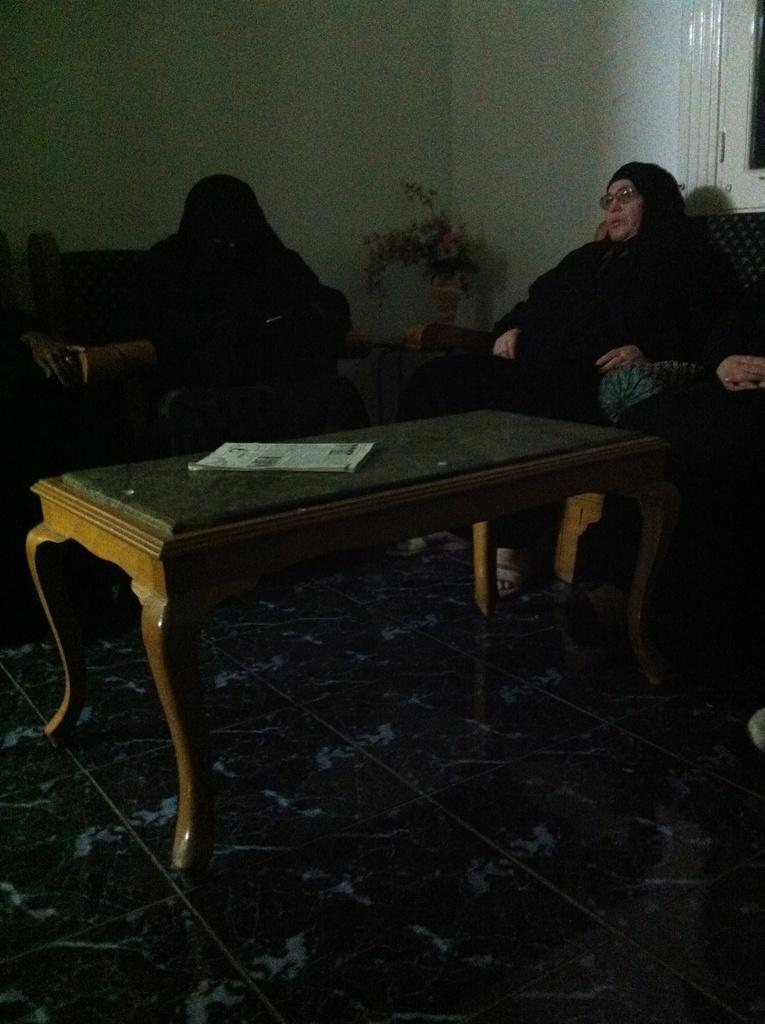Please provide a concise description of this image. There is a woman sitting in sofa and a table in front of her with a paper on it. 